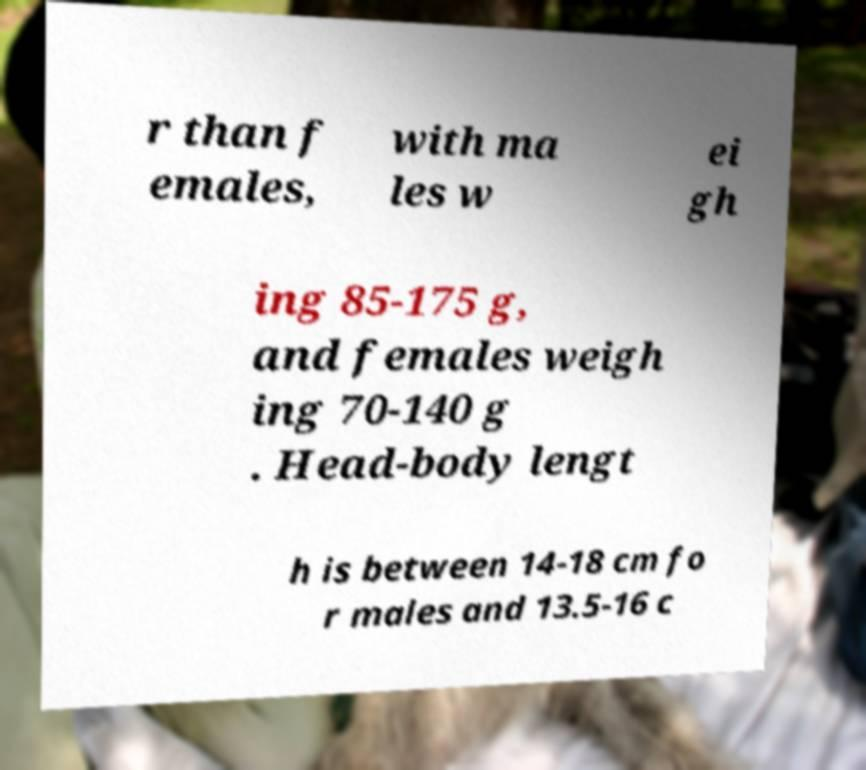Please identify and transcribe the text found in this image. r than f emales, with ma les w ei gh ing 85-175 g, and females weigh ing 70-140 g . Head-body lengt h is between 14-18 cm fo r males and 13.5-16 c 